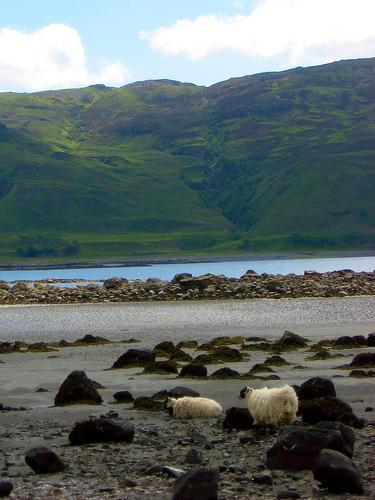How many sheep are there?
Give a very brief answer. 2. 